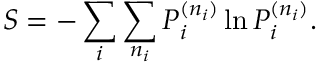Convert formula to latex. <formula><loc_0><loc_0><loc_500><loc_500>S = - \sum _ { i } \sum _ { n _ { i } } P _ { i } ^ { ( n _ { i } ) } \ln P _ { i } ^ { ( n _ { i } ) } .</formula> 